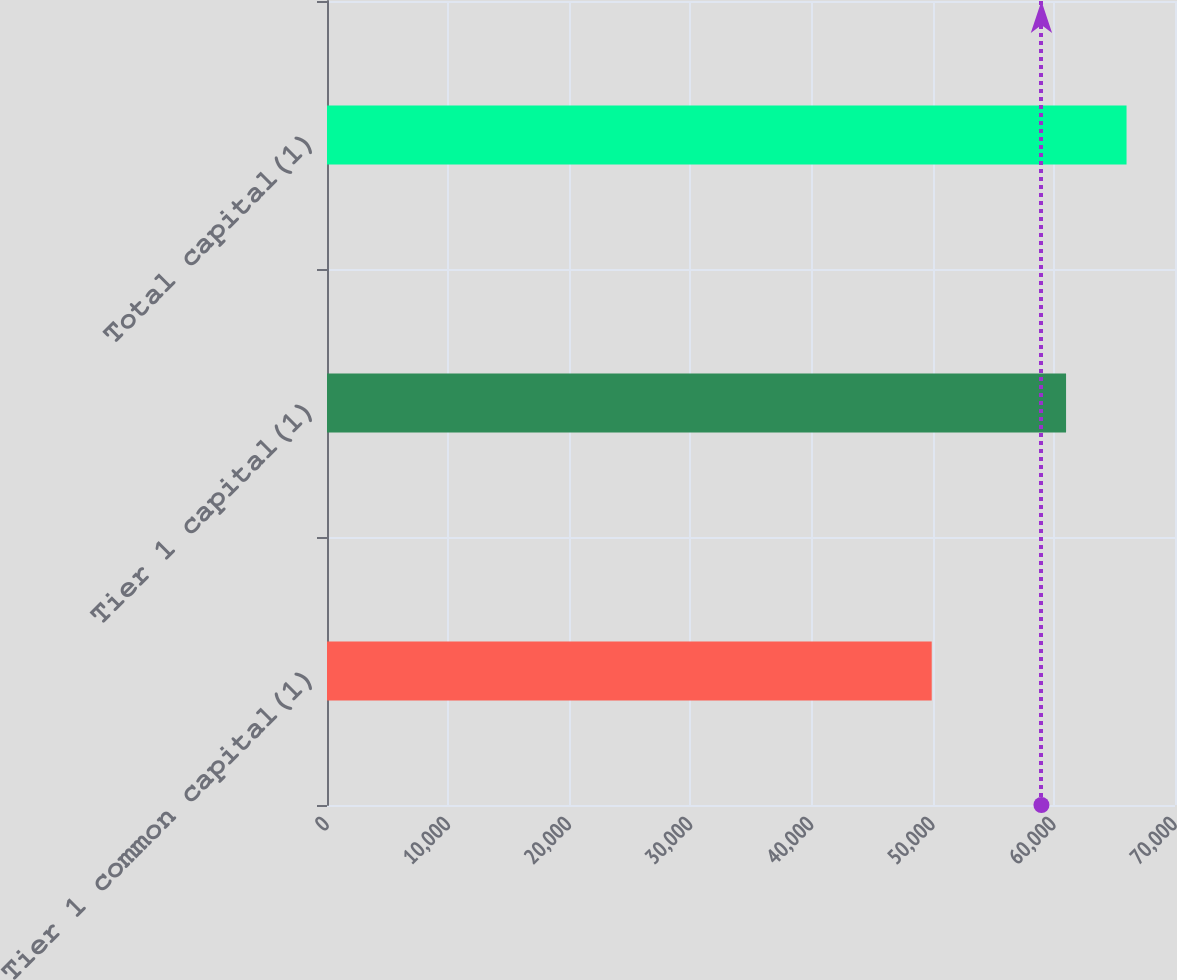Convert chart to OTSL. <chart><loc_0><loc_0><loc_500><loc_500><bar_chart><fcel>Tier 1 common capital(1)<fcel>Tier 1 capital(1)<fcel>Total capital(1)<nl><fcel>49917<fcel>61007<fcel>66000<nl></chart> 